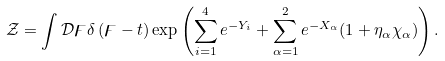<formula> <loc_0><loc_0><loc_500><loc_500>\mathcal { Z } = \int \mathcal { D } \digamma \delta \left ( \digamma - t \right ) \exp \left ( \sum _ { i = 1 } ^ { 4 } e ^ { - Y _ { i } } + \sum _ { \alpha = 1 } ^ { 2 } e ^ { - X _ { \alpha } } ( 1 + \eta _ { \alpha } \chi _ { \alpha } ) \right ) .</formula> 